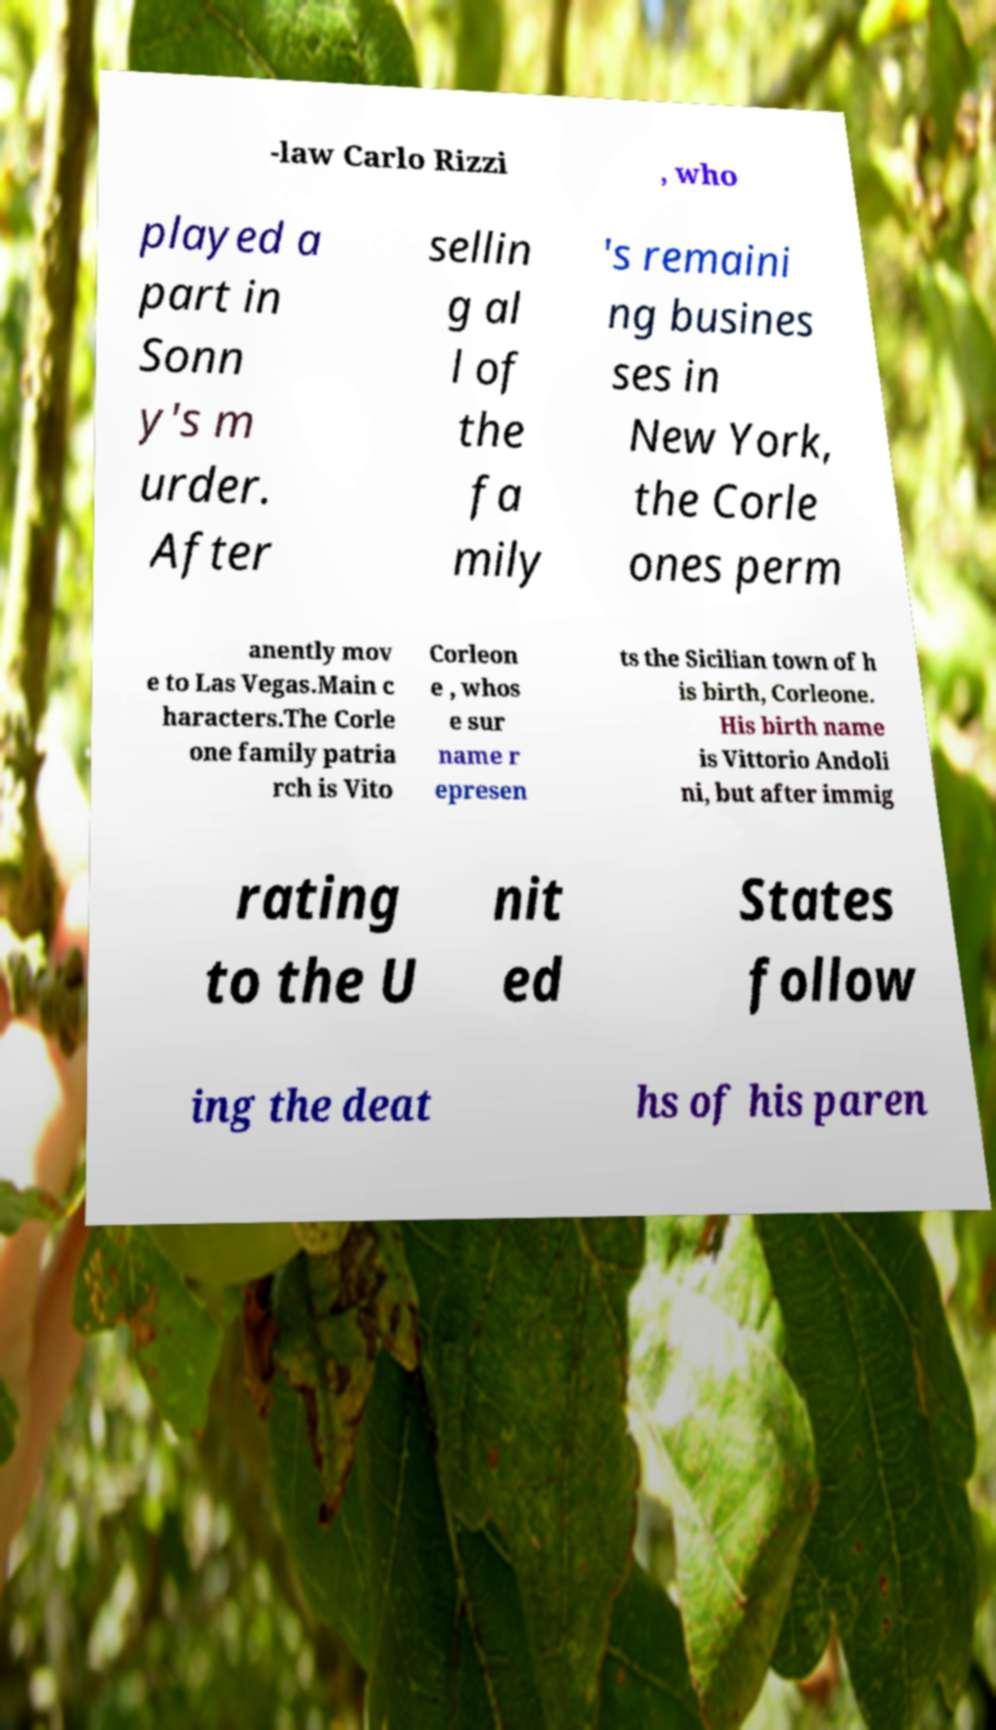Could you assist in decoding the text presented in this image and type it out clearly? -law Carlo Rizzi , who played a part in Sonn y's m urder. After sellin g al l of the fa mily 's remaini ng busines ses in New York, the Corle ones perm anently mov e to Las Vegas.Main c haracters.The Corle one family patria rch is Vito Corleon e , whos e sur name r epresen ts the Sicilian town of h is birth, Corleone. His birth name is Vittorio Andoli ni, but after immig rating to the U nit ed States follow ing the deat hs of his paren 